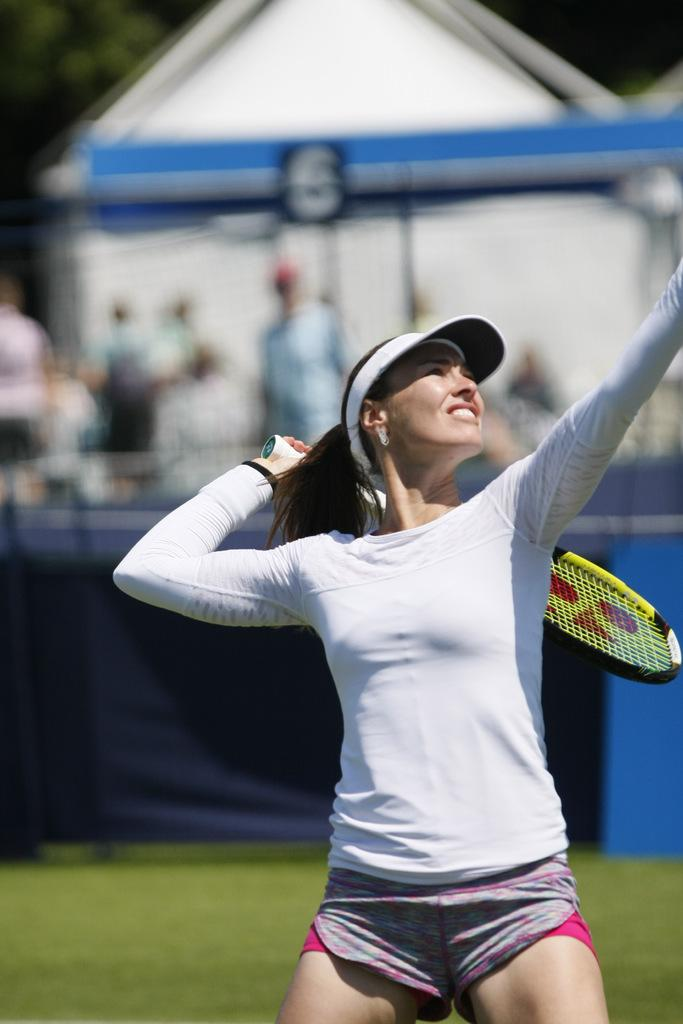What is the main subject of the image? There is a person in the image. What is the person doing in the image? The person is on the ground and holding a racket. What clothing items is the person wearing? The person is wearing a white t-shirt and a cap. How would you describe the background of the image? The background of the image is blurry. What time of day is it in the image, based on the hour shown on the person's wristwatch? There is no wristwatch visible in the image, so we cannot determine the time of day based on an hour shown on it. 